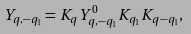<formula> <loc_0><loc_0><loc_500><loc_500>Y _ { q , - q _ { 1 } } = K _ { q } Y _ { q , - q _ { 1 } } ^ { 0 } K _ { q _ { 1 } } K _ { q - q _ { 1 } } ,</formula> 